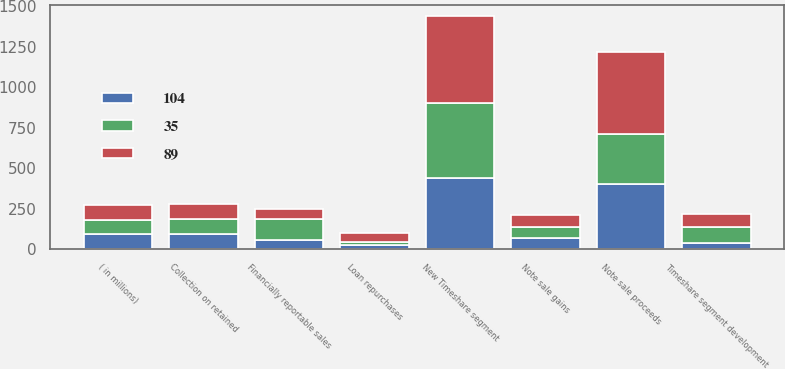<chart> <loc_0><loc_0><loc_500><loc_500><stacked_bar_chart><ecel><fcel>( in millions)<fcel>Timeshare segment development<fcel>New Timeshare segment<fcel>Loan repurchases<fcel>Note sale gains<fcel>Note sale proceeds<fcel>Financially reportable sales<fcel>Collection on retained<nl><fcel>89<fcel>90<fcel>83<fcel>537<fcel>55<fcel>77<fcel>508<fcel>61<fcel>96<nl><fcel>104<fcel>90<fcel>40<fcel>441<fcel>23<fcel>69<fcel>399<fcel>57<fcel>90<nl><fcel>35<fcel>90<fcel>93<fcel>459<fcel>18<fcel>64<fcel>312<fcel>129<fcel>94<nl></chart> 